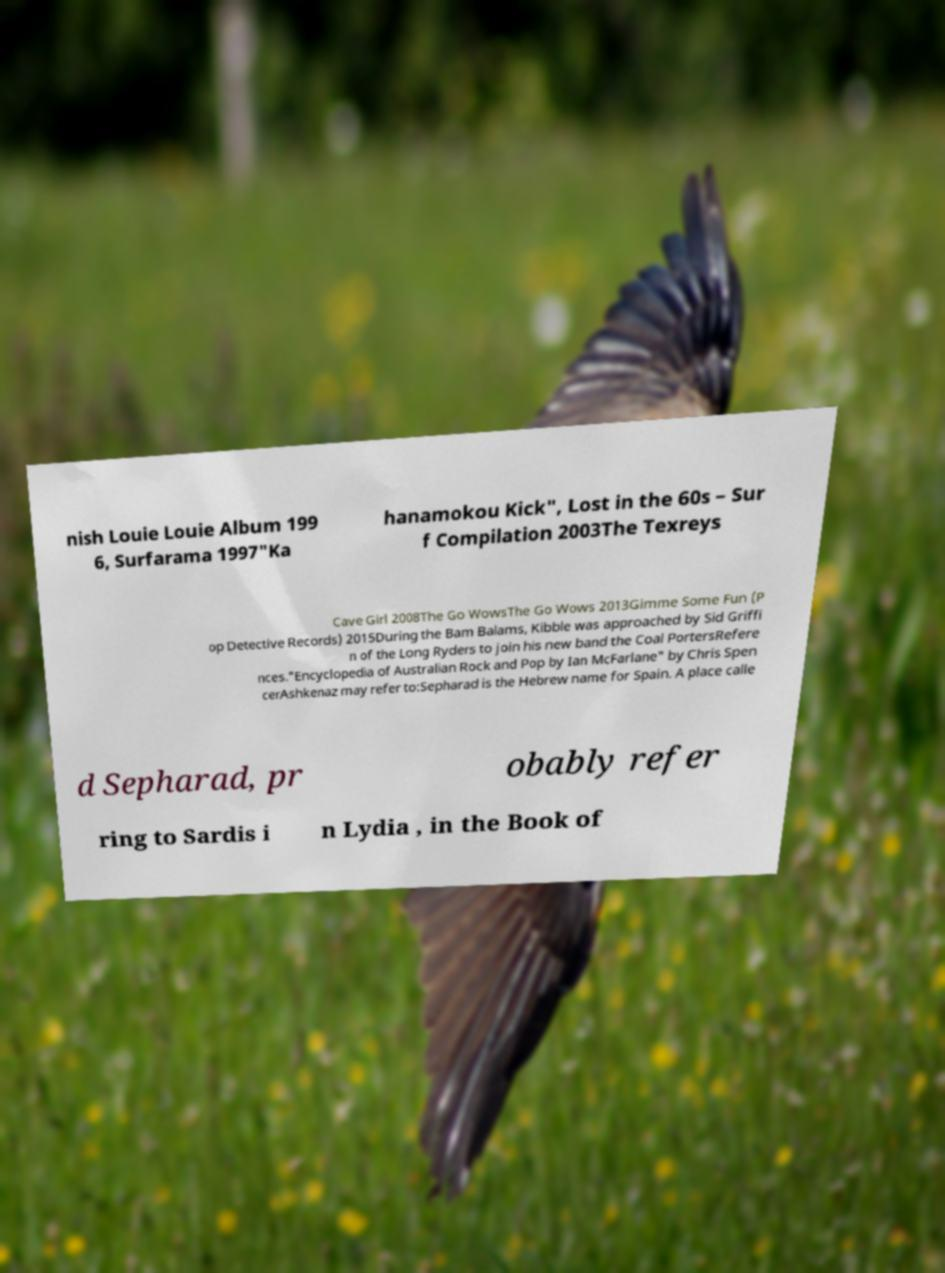Please identify and transcribe the text found in this image. nish Louie Louie Album 199 6, Surfarama 1997"Ka hanamokou Kick", Lost in the 60s – Sur f Compilation 2003The Texreys Cave Girl 2008The Go WowsThe Go Wows 2013Gimme Some Fun (P op Detective Records) 2015During the Bam Balams, Kibble was approached by Sid Griffi n of the Long Ryders to join his new band the Coal PortersRefere nces."Encyclopedia of Australian Rock and Pop by Ian McFarlane" by Chris Spen cerAshkenaz may refer to:Sepharad is the Hebrew name for Spain. A place calle d Sepharad, pr obably refer ring to Sardis i n Lydia , in the Book of 